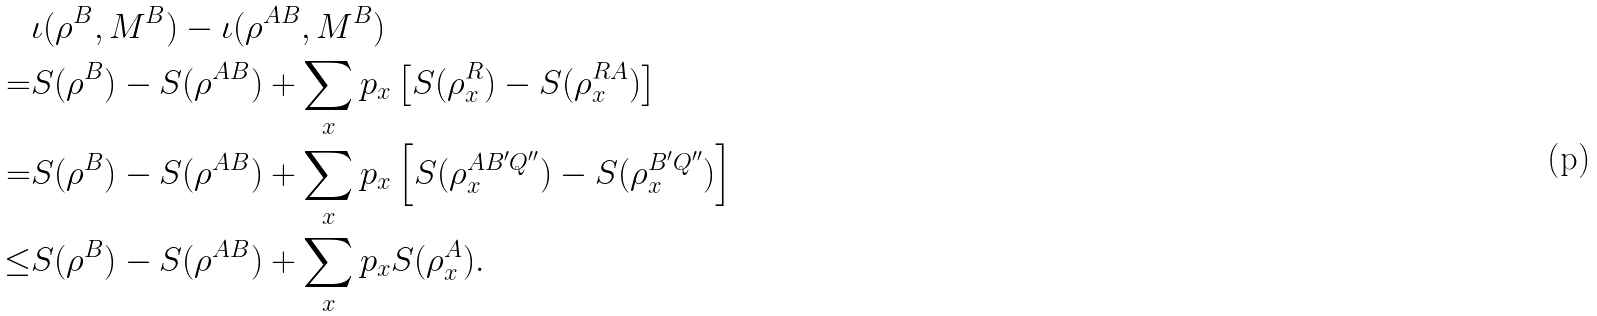<formula> <loc_0><loc_0><loc_500><loc_500>& \iota ( \rho ^ { B } , M ^ { B } ) - \iota ( \rho ^ { A B } , M ^ { B } ) \\ = & S ( \rho ^ { B } ) - S ( \rho ^ { A B } ) + \sum _ { x } p _ { x } \left [ S ( \rho ^ { R } _ { x } ) - S ( \rho ^ { R A } _ { x } ) \right ] \\ = & S ( \rho ^ { B } ) - S ( \rho ^ { A B } ) + \sum _ { x } p _ { x } \left [ S ( \rho ^ { A B ^ { \prime } Q ^ { \prime \prime } } _ { x } ) - S ( \rho ^ { B ^ { \prime } Q ^ { \prime \prime } } _ { x } ) \right ] \\ \leq & S ( \rho ^ { B } ) - S ( \rho ^ { A B } ) + \sum _ { x } p _ { x } S ( \rho ^ { A } _ { x } ) .</formula> 